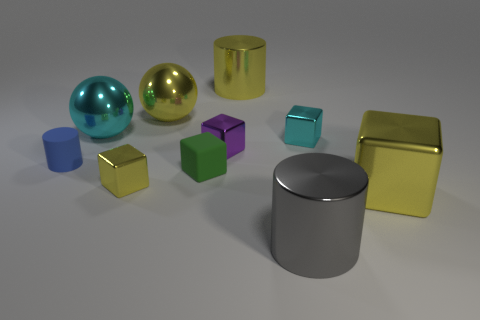There is a tiny metallic cube in front of the small blue thing; is its color the same as the small cylinder? no 